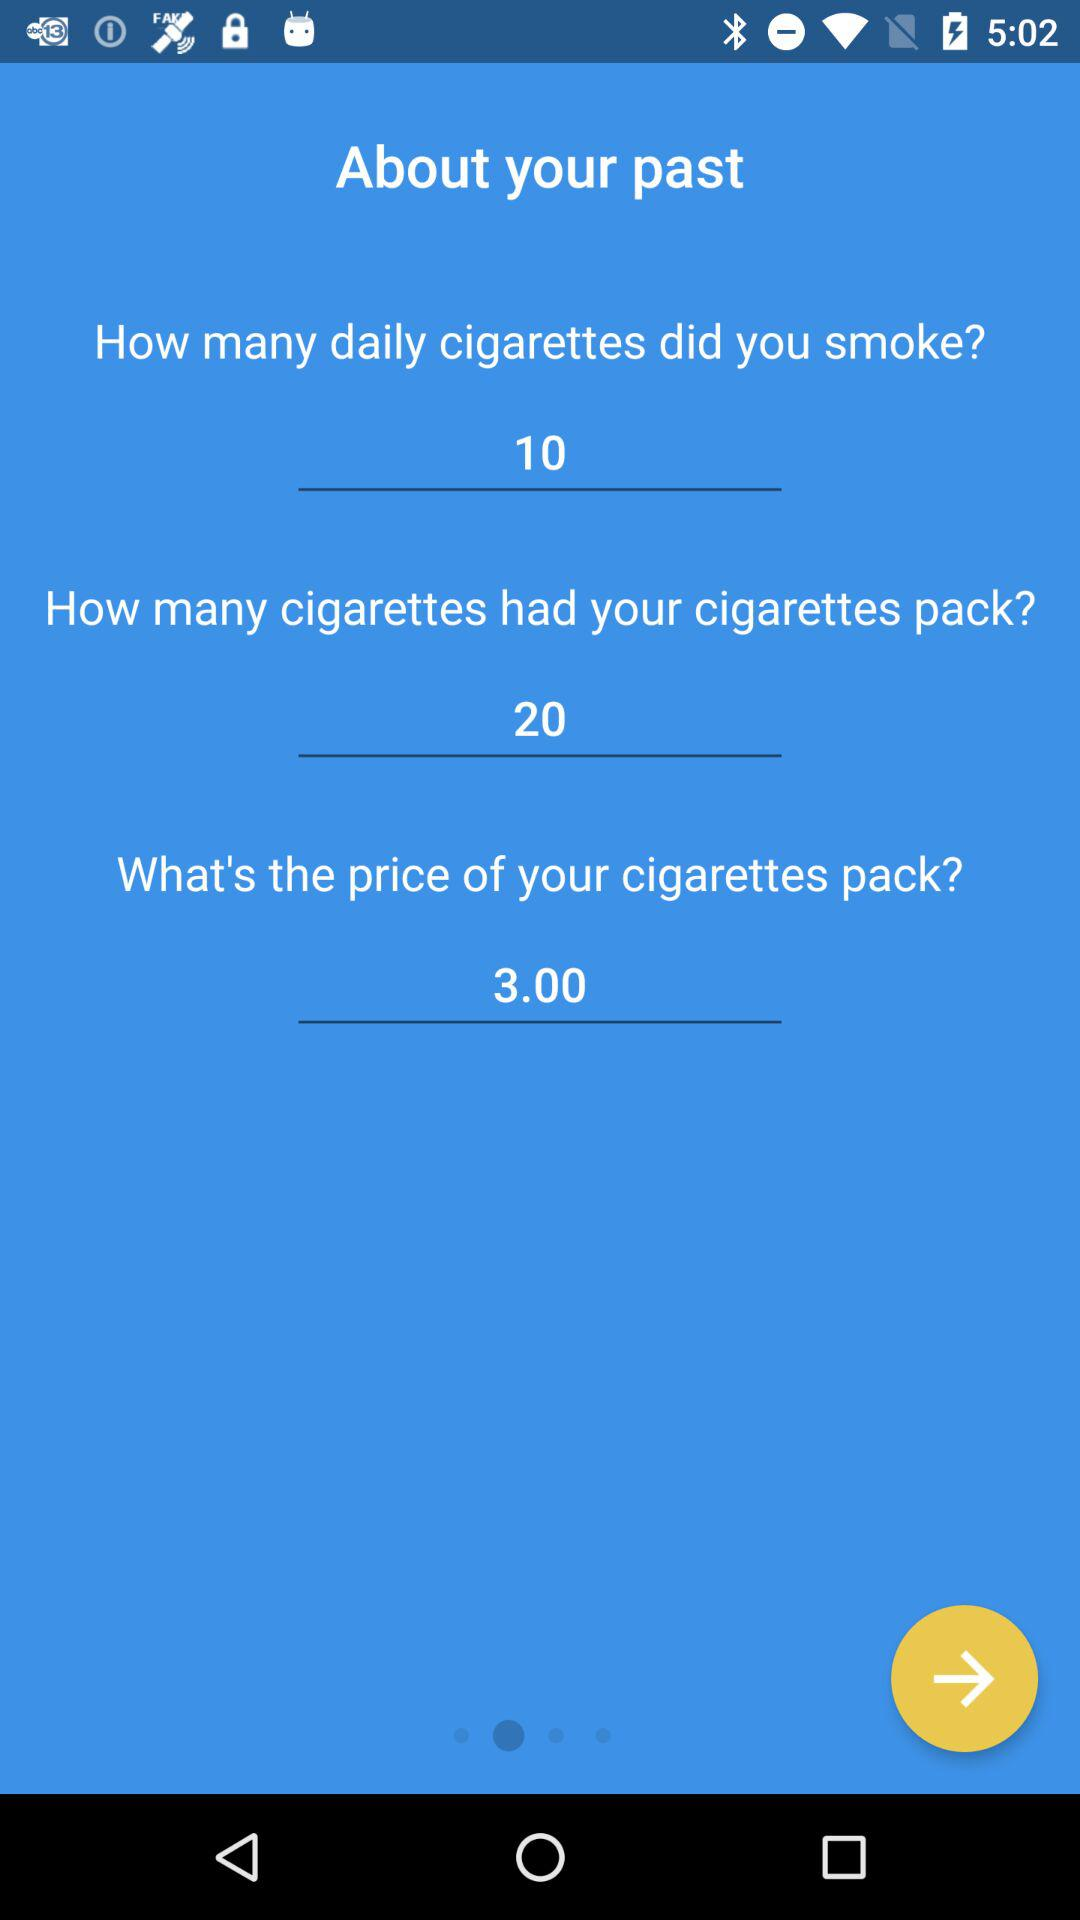How many cigarettes did I smoke per day? You smoked 10 cigarettes per day. 